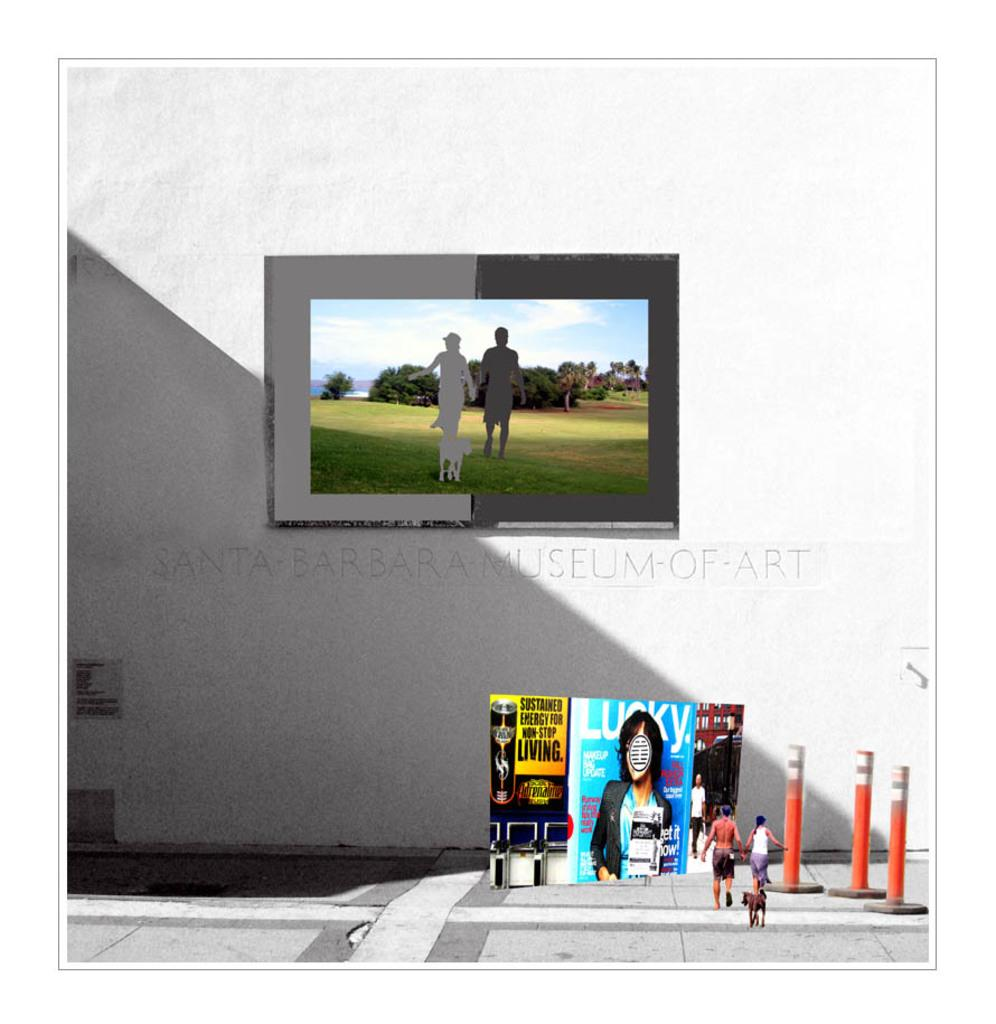How many people are in the image? There are two persons in the image. What other living creature is present in the image? There is a dog in the image. What type of decorations can be seen in the image? There are posters in the image. What architectural elements are visible in the image? There are poles and a frame attached to the wall in the image. How does the fly control the posters in the image? There is no fly present in the image, so it cannot control the posters. 